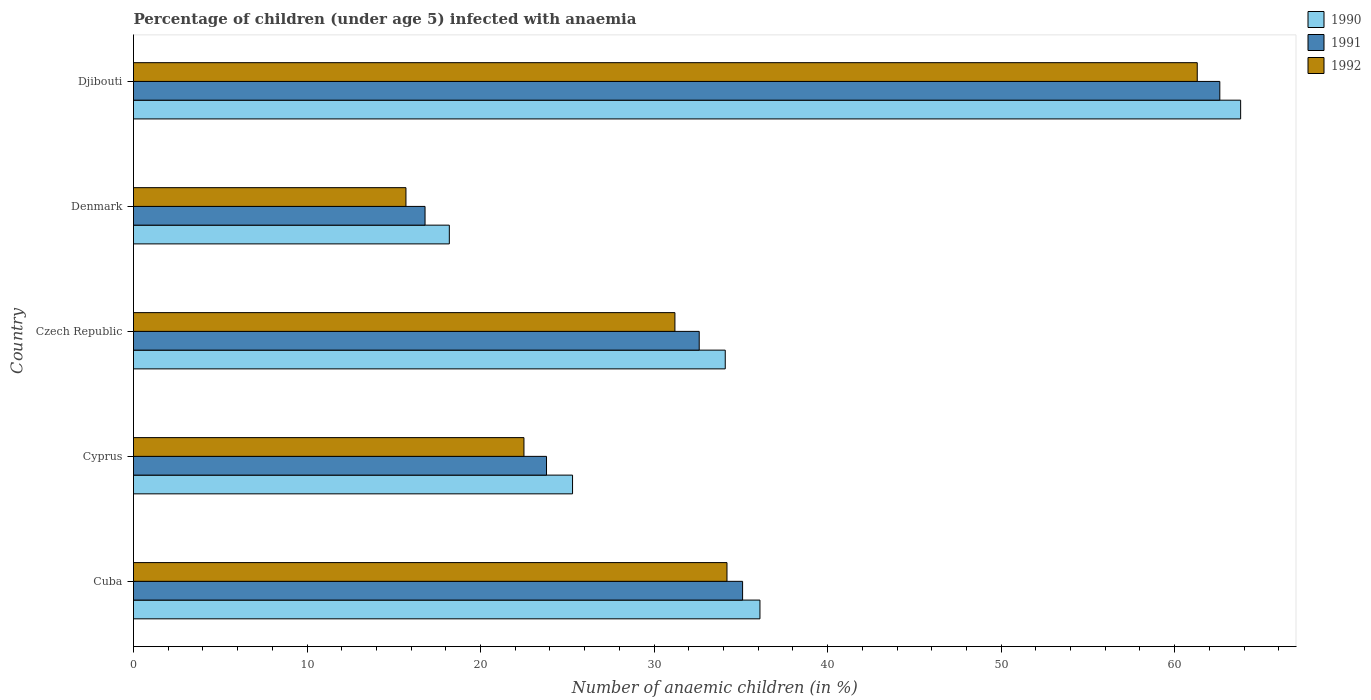How many groups of bars are there?
Make the answer very short. 5. Are the number of bars per tick equal to the number of legend labels?
Your answer should be very brief. Yes. How many bars are there on the 5th tick from the top?
Keep it short and to the point. 3. How many bars are there on the 2nd tick from the bottom?
Ensure brevity in your answer.  3. What is the label of the 1st group of bars from the top?
Provide a succinct answer. Djibouti. In how many cases, is the number of bars for a given country not equal to the number of legend labels?
Offer a very short reply. 0. What is the percentage of children infected with anaemia in in 1990 in Djibouti?
Offer a terse response. 63.8. Across all countries, what is the maximum percentage of children infected with anaemia in in 1991?
Provide a short and direct response. 62.6. Across all countries, what is the minimum percentage of children infected with anaemia in in 1992?
Offer a very short reply. 15.7. In which country was the percentage of children infected with anaemia in in 1990 maximum?
Make the answer very short. Djibouti. What is the total percentage of children infected with anaemia in in 1992 in the graph?
Provide a short and direct response. 164.9. What is the difference between the percentage of children infected with anaemia in in 1990 in Denmark and that in Djibouti?
Provide a succinct answer. -45.6. What is the difference between the percentage of children infected with anaemia in in 1990 in Cuba and the percentage of children infected with anaemia in in 1992 in Czech Republic?
Your answer should be compact. 4.9. What is the average percentage of children infected with anaemia in in 1992 per country?
Ensure brevity in your answer.  32.98. What is the difference between the percentage of children infected with anaemia in in 1990 and percentage of children infected with anaemia in in 1991 in Cyprus?
Offer a terse response. 1.5. In how many countries, is the percentage of children infected with anaemia in in 1990 greater than 32 %?
Your answer should be compact. 3. What is the ratio of the percentage of children infected with anaemia in in 1990 in Denmark to that in Djibouti?
Your response must be concise. 0.29. Is the percentage of children infected with anaemia in in 1990 in Cyprus less than that in Denmark?
Your answer should be very brief. No. What is the difference between the highest and the lowest percentage of children infected with anaemia in in 1992?
Offer a very short reply. 45.6. What does the 1st bar from the bottom in Czech Republic represents?
Your response must be concise. 1990. Is it the case that in every country, the sum of the percentage of children infected with anaemia in in 1992 and percentage of children infected with anaemia in in 1991 is greater than the percentage of children infected with anaemia in in 1990?
Keep it short and to the point. Yes. Are all the bars in the graph horizontal?
Your answer should be compact. Yes. What is the difference between two consecutive major ticks on the X-axis?
Offer a very short reply. 10. Does the graph contain any zero values?
Provide a short and direct response. No. Does the graph contain grids?
Make the answer very short. No. How many legend labels are there?
Offer a terse response. 3. What is the title of the graph?
Offer a terse response. Percentage of children (under age 5) infected with anaemia. Does "1993" appear as one of the legend labels in the graph?
Make the answer very short. No. What is the label or title of the X-axis?
Provide a short and direct response. Number of anaemic children (in %). What is the Number of anaemic children (in %) in 1990 in Cuba?
Ensure brevity in your answer.  36.1. What is the Number of anaemic children (in %) of 1991 in Cuba?
Make the answer very short. 35.1. What is the Number of anaemic children (in %) of 1992 in Cuba?
Ensure brevity in your answer.  34.2. What is the Number of anaemic children (in %) of 1990 in Cyprus?
Give a very brief answer. 25.3. What is the Number of anaemic children (in %) in 1991 in Cyprus?
Keep it short and to the point. 23.8. What is the Number of anaemic children (in %) of 1992 in Cyprus?
Offer a very short reply. 22.5. What is the Number of anaemic children (in %) of 1990 in Czech Republic?
Keep it short and to the point. 34.1. What is the Number of anaemic children (in %) in 1991 in Czech Republic?
Make the answer very short. 32.6. What is the Number of anaemic children (in %) in 1992 in Czech Republic?
Provide a short and direct response. 31.2. What is the Number of anaemic children (in %) in 1990 in Djibouti?
Your answer should be very brief. 63.8. What is the Number of anaemic children (in %) of 1991 in Djibouti?
Your answer should be very brief. 62.6. What is the Number of anaemic children (in %) in 1992 in Djibouti?
Make the answer very short. 61.3. Across all countries, what is the maximum Number of anaemic children (in %) of 1990?
Provide a succinct answer. 63.8. Across all countries, what is the maximum Number of anaemic children (in %) of 1991?
Provide a short and direct response. 62.6. Across all countries, what is the maximum Number of anaemic children (in %) of 1992?
Keep it short and to the point. 61.3. Across all countries, what is the minimum Number of anaemic children (in %) in 1991?
Offer a terse response. 16.8. What is the total Number of anaemic children (in %) in 1990 in the graph?
Provide a short and direct response. 177.5. What is the total Number of anaemic children (in %) of 1991 in the graph?
Your response must be concise. 170.9. What is the total Number of anaemic children (in %) in 1992 in the graph?
Make the answer very short. 164.9. What is the difference between the Number of anaemic children (in %) in 1992 in Cuba and that in Cyprus?
Give a very brief answer. 11.7. What is the difference between the Number of anaemic children (in %) of 1991 in Cuba and that in Czech Republic?
Your answer should be very brief. 2.5. What is the difference between the Number of anaemic children (in %) in 1992 in Cuba and that in Czech Republic?
Keep it short and to the point. 3. What is the difference between the Number of anaemic children (in %) of 1992 in Cuba and that in Denmark?
Your response must be concise. 18.5. What is the difference between the Number of anaemic children (in %) in 1990 in Cuba and that in Djibouti?
Ensure brevity in your answer.  -27.7. What is the difference between the Number of anaemic children (in %) in 1991 in Cuba and that in Djibouti?
Offer a terse response. -27.5. What is the difference between the Number of anaemic children (in %) in 1992 in Cuba and that in Djibouti?
Provide a succinct answer. -27.1. What is the difference between the Number of anaemic children (in %) in 1990 in Cyprus and that in Czech Republic?
Your answer should be compact. -8.8. What is the difference between the Number of anaemic children (in %) in 1990 in Cyprus and that in Djibouti?
Your response must be concise. -38.5. What is the difference between the Number of anaemic children (in %) in 1991 in Cyprus and that in Djibouti?
Ensure brevity in your answer.  -38.8. What is the difference between the Number of anaemic children (in %) in 1992 in Cyprus and that in Djibouti?
Offer a very short reply. -38.8. What is the difference between the Number of anaemic children (in %) of 1990 in Czech Republic and that in Denmark?
Offer a terse response. 15.9. What is the difference between the Number of anaemic children (in %) of 1992 in Czech Republic and that in Denmark?
Keep it short and to the point. 15.5. What is the difference between the Number of anaemic children (in %) of 1990 in Czech Republic and that in Djibouti?
Provide a short and direct response. -29.7. What is the difference between the Number of anaemic children (in %) of 1991 in Czech Republic and that in Djibouti?
Keep it short and to the point. -30. What is the difference between the Number of anaemic children (in %) in 1992 in Czech Republic and that in Djibouti?
Make the answer very short. -30.1. What is the difference between the Number of anaemic children (in %) of 1990 in Denmark and that in Djibouti?
Ensure brevity in your answer.  -45.6. What is the difference between the Number of anaemic children (in %) in 1991 in Denmark and that in Djibouti?
Offer a very short reply. -45.8. What is the difference between the Number of anaemic children (in %) of 1992 in Denmark and that in Djibouti?
Your response must be concise. -45.6. What is the difference between the Number of anaemic children (in %) of 1991 in Cuba and the Number of anaemic children (in %) of 1992 in Cyprus?
Your response must be concise. 12.6. What is the difference between the Number of anaemic children (in %) in 1990 in Cuba and the Number of anaemic children (in %) in 1991 in Czech Republic?
Ensure brevity in your answer.  3.5. What is the difference between the Number of anaemic children (in %) of 1990 in Cuba and the Number of anaemic children (in %) of 1991 in Denmark?
Your answer should be very brief. 19.3. What is the difference between the Number of anaemic children (in %) in 1990 in Cuba and the Number of anaemic children (in %) in 1992 in Denmark?
Your response must be concise. 20.4. What is the difference between the Number of anaemic children (in %) in 1990 in Cuba and the Number of anaemic children (in %) in 1991 in Djibouti?
Offer a very short reply. -26.5. What is the difference between the Number of anaemic children (in %) in 1990 in Cuba and the Number of anaemic children (in %) in 1992 in Djibouti?
Give a very brief answer. -25.2. What is the difference between the Number of anaemic children (in %) of 1991 in Cuba and the Number of anaemic children (in %) of 1992 in Djibouti?
Give a very brief answer. -26.2. What is the difference between the Number of anaemic children (in %) of 1990 in Cyprus and the Number of anaemic children (in %) of 1991 in Czech Republic?
Your response must be concise. -7.3. What is the difference between the Number of anaemic children (in %) in 1990 in Cyprus and the Number of anaemic children (in %) in 1991 in Denmark?
Offer a terse response. 8.5. What is the difference between the Number of anaemic children (in %) of 1990 in Cyprus and the Number of anaemic children (in %) of 1992 in Denmark?
Ensure brevity in your answer.  9.6. What is the difference between the Number of anaemic children (in %) of 1990 in Cyprus and the Number of anaemic children (in %) of 1991 in Djibouti?
Ensure brevity in your answer.  -37.3. What is the difference between the Number of anaemic children (in %) of 1990 in Cyprus and the Number of anaemic children (in %) of 1992 in Djibouti?
Make the answer very short. -36. What is the difference between the Number of anaemic children (in %) in 1991 in Cyprus and the Number of anaemic children (in %) in 1992 in Djibouti?
Keep it short and to the point. -37.5. What is the difference between the Number of anaemic children (in %) in 1991 in Czech Republic and the Number of anaemic children (in %) in 1992 in Denmark?
Provide a short and direct response. 16.9. What is the difference between the Number of anaemic children (in %) of 1990 in Czech Republic and the Number of anaemic children (in %) of 1991 in Djibouti?
Your answer should be compact. -28.5. What is the difference between the Number of anaemic children (in %) of 1990 in Czech Republic and the Number of anaemic children (in %) of 1992 in Djibouti?
Offer a terse response. -27.2. What is the difference between the Number of anaemic children (in %) of 1991 in Czech Republic and the Number of anaemic children (in %) of 1992 in Djibouti?
Provide a short and direct response. -28.7. What is the difference between the Number of anaemic children (in %) in 1990 in Denmark and the Number of anaemic children (in %) in 1991 in Djibouti?
Offer a terse response. -44.4. What is the difference between the Number of anaemic children (in %) of 1990 in Denmark and the Number of anaemic children (in %) of 1992 in Djibouti?
Ensure brevity in your answer.  -43.1. What is the difference between the Number of anaemic children (in %) of 1991 in Denmark and the Number of anaemic children (in %) of 1992 in Djibouti?
Give a very brief answer. -44.5. What is the average Number of anaemic children (in %) in 1990 per country?
Give a very brief answer. 35.5. What is the average Number of anaemic children (in %) of 1991 per country?
Make the answer very short. 34.18. What is the average Number of anaemic children (in %) of 1992 per country?
Your answer should be very brief. 32.98. What is the difference between the Number of anaemic children (in %) in 1990 and Number of anaemic children (in %) in 1991 in Cuba?
Make the answer very short. 1. What is the difference between the Number of anaemic children (in %) in 1990 and Number of anaemic children (in %) in 1992 in Cyprus?
Keep it short and to the point. 2.8. What is the difference between the Number of anaemic children (in %) of 1990 and Number of anaemic children (in %) of 1992 in Czech Republic?
Offer a very short reply. 2.9. What is the difference between the Number of anaemic children (in %) of 1991 and Number of anaemic children (in %) of 1992 in Czech Republic?
Your answer should be very brief. 1.4. What is the difference between the Number of anaemic children (in %) in 1990 and Number of anaemic children (in %) in 1992 in Denmark?
Ensure brevity in your answer.  2.5. What is the difference between the Number of anaemic children (in %) of 1991 and Number of anaemic children (in %) of 1992 in Denmark?
Provide a short and direct response. 1.1. What is the difference between the Number of anaemic children (in %) in 1990 and Number of anaemic children (in %) in 1991 in Djibouti?
Make the answer very short. 1.2. What is the difference between the Number of anaemic children (in %) of 1990 and Number of anaemic children (in %) of 1992 in Djibouti?
Provide a succinct answer. 2.5. What is the ratio of the Number of anaemic children (in %) of 1990 in Cuba to that in Cyprus?
Your response must be concise. 1.43. What is the ratio of the Number of anaemic children (in %) in 1991 in Cuba to that in Cyprus?
Keep it short and to the point. 1.47. What is the ratio of the Number of anaemic children (in %) in 1992 in Cuba to that in Cyprus?
Your answer should be very brief. 1.52. What is the ratio of the Number of anaemic children (in %) of 1990 in Cuba to that in Czech Republic?
Make the answer very short. 1.06. What is the ratio of the Number of anaemic children (in %) in 1991 in Cuba to that in Czech Republic?
Keep it short and to the point. 1.08. What is the ratio of the Number of anaemic children (in %) of 1992 in Cuba to that in Czech Republic?
Provide a short and direct response. 1.1. What is the ratio of the Number of anaemic children (in %) of 1990 in Cuba to that in Denmark?
Provide a succinct answer. 1.98. What is the ratio of the Number of anaemic children (in %) in 1991 in Cuba to that in Denmark?
Make the answer very short. 2.09. What is the ratio of the Number of anaemic children (in %) of 1992 in Cuba to that in Denmark?
Provide a succinct answer. 2.18. What is the ratio of the Number of anaemic children (in %) in 1990 in Cuba to that in Djibouti?
Your answer should be very brief. 0.57. What is the ratio of the Number of anaemic children (in %) of 1991 in Cuba to that in Djibouti?
Your answer should be compact. 0.56. What is the ratio of the Number of anaemic children (in %) in 1992 in Cuba to that in Djibouti?
Offer a terse response. 0.56. What is the ratio of the Number of anaemic children (in %) in 1990 in Cyprus to that in Czech Republic?
Provide a short and direct response. 0.74. What is the ratio of the Number of anaemic children (in %) in 1991 in Cyprus to that in Czech Republic?
Provide a succinct answer. 0.73. What is the ratio of the Number of anaemic children (in %) in 1992 in Cyprus to that in Czech Republic?
Make the answer very short. 0.72. What is the ratio of the Number of anaemic children (in %) in 1990 in Cyprus to that in Denmark?
Provide a short and direct response. 1.39. What is the ratio of the Number of anaemic children (in %) in 1991 in Cyprus to that in Denmark?
Your answer should be compact. 1.42. What is the ratio of the Number of anaemic children (in %) in 1992 in Cyprus to that in Denmark?
Your response must be concise. 1.43. What is the ratio of the Number of anaemic children (in %) of 1990 in Cyprus to that in Djibouti?
Your answer should be very brief. 0.4. What is the ratio of the Number of anaemic children (in %) of 1991 in Cyprus to that in Djibouti?
Your answer should be compact. 0.38. What is the ratio of the Number of anaemic children (in %) in 1992 in Cyprus to that in Djibouti?
Make the answer very short. 0.37. What is the ratio of the Number of anaemic children (in %) in 1990 in Czech Republic to that in Denmark?
Provide a short and direct response. 1.87. What is the ratio of the Number of anaemic children (in %) of 1991 in Czech Republic to that in Denmark?
Provide a succinct answer. 1.94. What is the ratio of the Number of anaemic children (in %) in 1992 in Czech Republic to that in Denmark?
Offer a very short reply. 1.99. What is the ratio of the Number of anaemic children (in %) in 1990 in Czech Republic to that in Djibouti?
Provide a short and direct response. 0.53. What is the ratio of the Number of anaemic children (in %) in 1991 in Czech Republic to that in Djibouti?
Offer a terse response. 0.52. What is the ratio of the Number of anaemic children (in %) of 1992 in Czech Republic to that in Djibouti?
Offer a terse response. 0.51. What is the ratio of the Number of anaemic children (in %) of 1990 in Denmark to that in Djibouti?
Give a very brief answer. 0.29. What is the ratio of the Number of anaemic children (in %) of 1991 in Denmark to that in Djibouti?
Ensure brevity in your answer.  0.27. What is the ratio of the Number of anaemic children (in %) in 1992 in Denmark to that in Djibouti?
Keep it short and to the point. 0.26. What is the difference between the highest and the second highest Number of anaemic children (in %) of 1990?
Ensure brevity in your answer.  27.7. What is the difference between the highest and the second highest Number of anaemic children (in %) in 1992?
Offer a very short reply. 27.1. What is the difference between the highest and the lowest Number of anaemic children (in %) in 1990?
Offer a very short reply. 45.6. What is the difference between the highest and the lowest Number of anaemic children (in %) of 1991?
Make the answer very short. 45.8. What is the difference between the highest and the lowest Number of anaemic children (in %) in 1992?
Your answer should be compact. 45.6. 